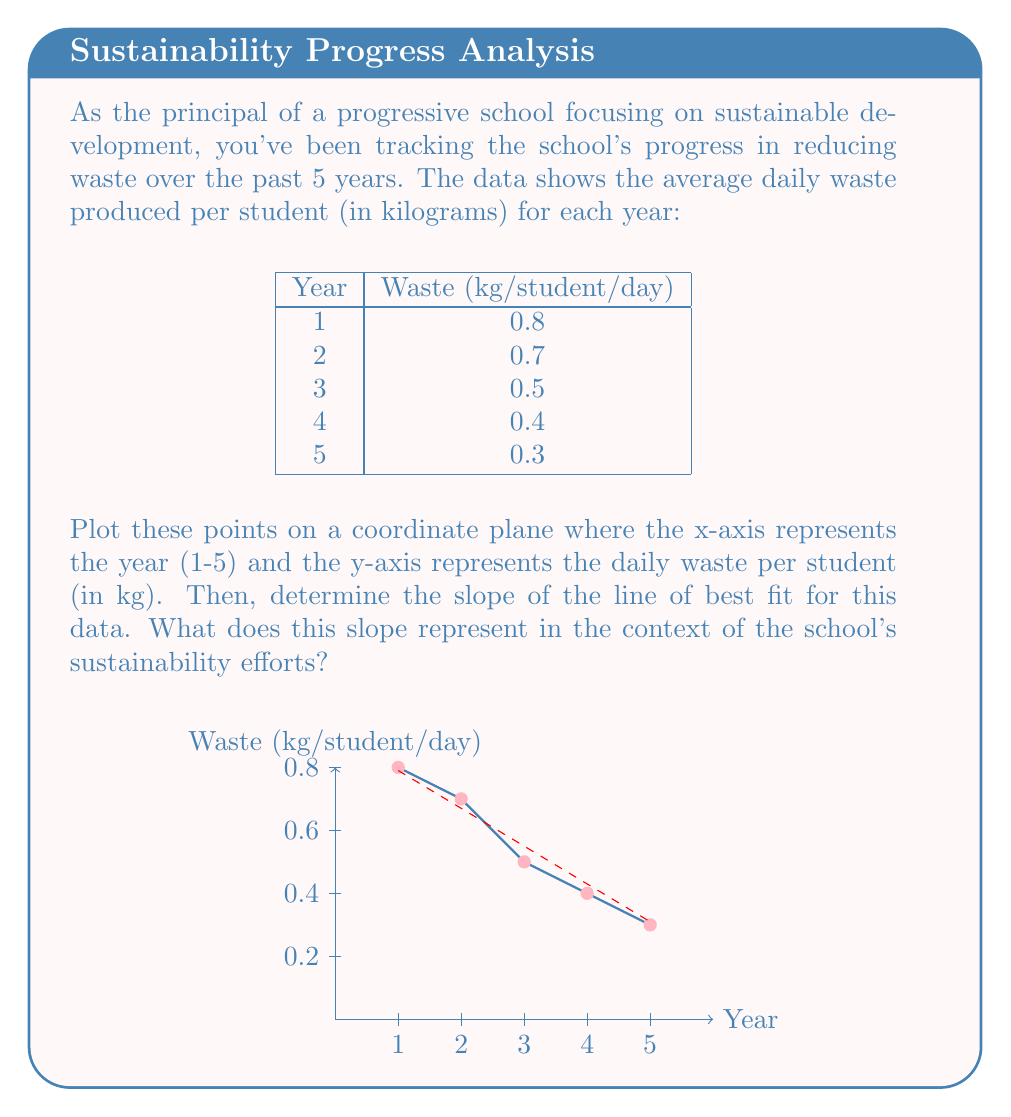What is the answer to this math problem? To solve this problem, we'll follow these steps:

1) Plot the points on the coordinate plane (as shown in the figure).

2) Calculate the slope of the line of best fit using the formula:

   $$m = \frac{\sum_{i=1}^n (x_i - \bar{x})(y_i - \bar{y})}{\sum_{i=1}^n (x_i - \bar{x})^2}$$

   where $(x_i, y_i)$ are the data points, and $(\bar{x}, \bar{y})$ are the means of x and y respectively.

3) First, calculate the means:
   $\bar{x} = \frac{1+2+3+4+5}{5} = 3$
   $\bar{y} = \frac{0.8+0.7+0.5+0.4+0.3}{5} = 0.54$

4) Now, calculate the numerator and denominator:

   Numerator: $\sum_{i=1}^n (x_i - \bar{x})(y_i - \bar{y})$
   $= (1-3)(0.8-0.54) + (2-3)(0.7-0.54) + (3-3)(0.5-0.54) + (4-3)(0.4-0.54) + (5-3)(0.3-0.54)$
   $= (-2)(0.26) + (-1)(0.16) + (0)(-0.04) + (1)(-0.14) + (2)(-0.24)$
   $= -0.52 - 0.16 + 0 - 0.14 - 0.48 = -1.3$

   Denominator: $\sum_{i=1}^n (x_i - \bar{x})^2$
   $= (-2)^2 + (-1)^2 + (0)^2 + (1)^2 + (2)^2$
   $= 4 + 1 + 0 + 1 + 4 = 10$

5) Calculate the slope:
   $m = \frac{-1.3}{10} = -0.13$

6) Interpret the result: The slope of -0.13 kg/year represents the average annual decrease in daily waste per student over the 5-year period.
Answer: $-0.13$ kg/year 